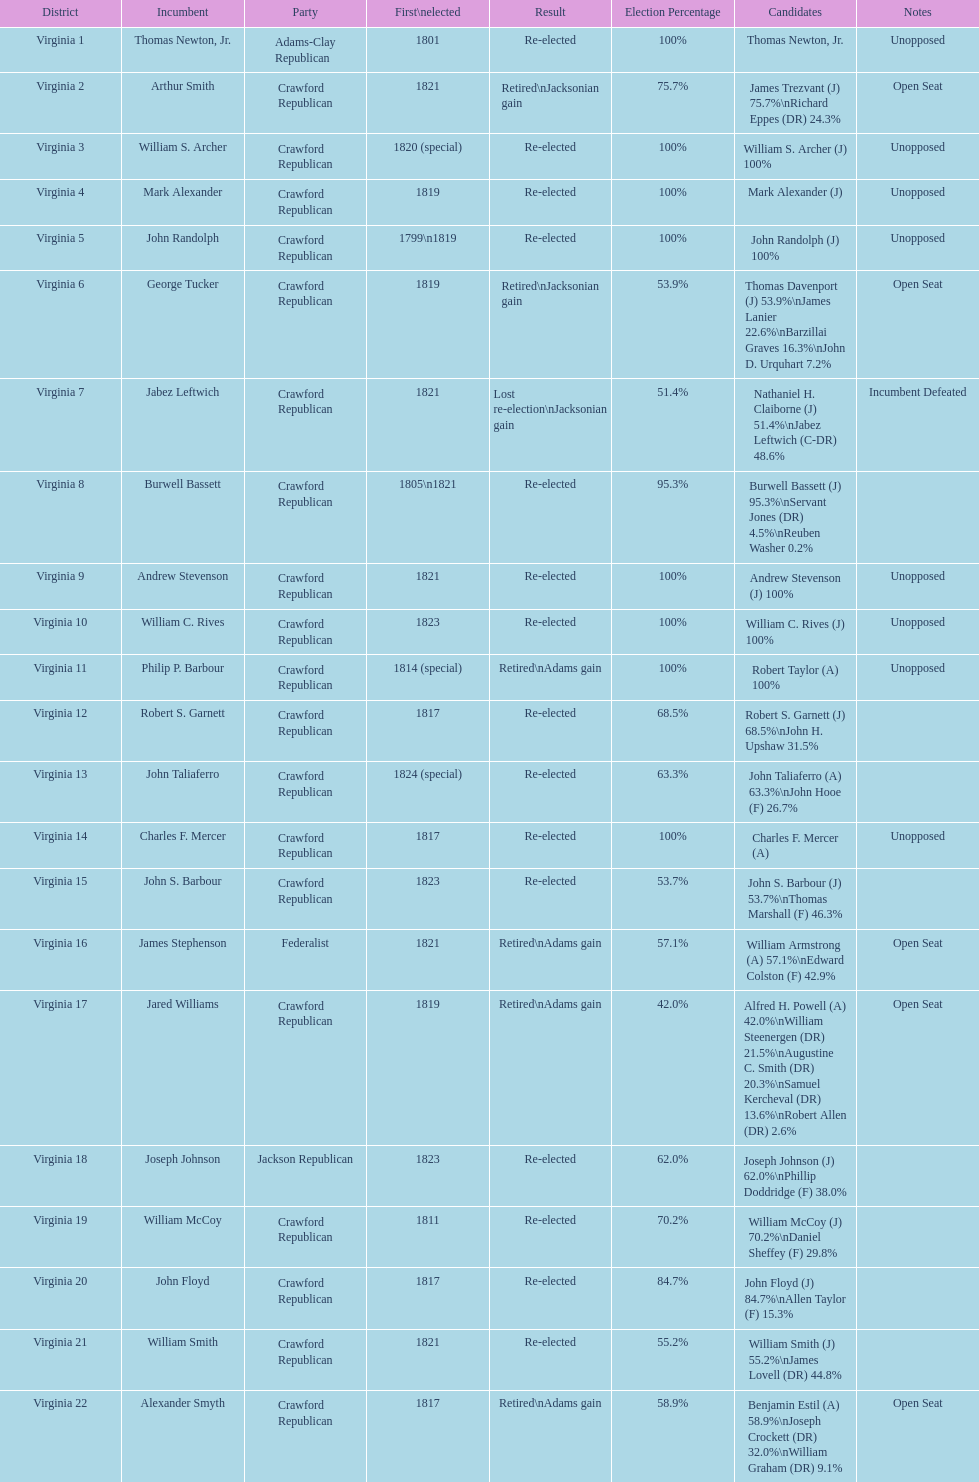How many candidates were there for virginia 17 district? 5. 